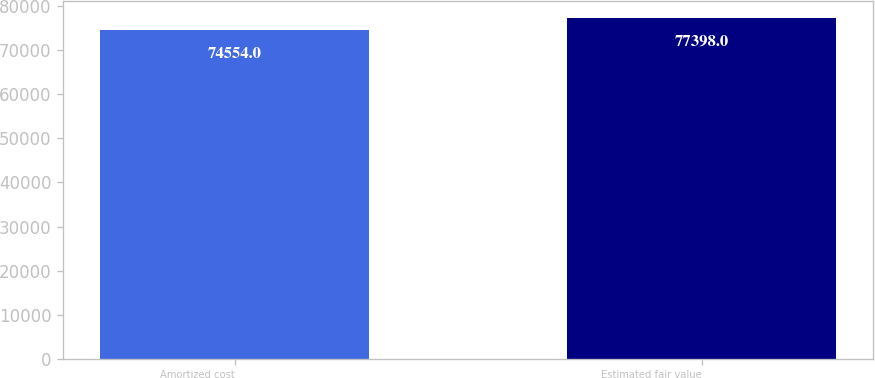<chart> <loc_0><loc_0><loc_500><loc_500><bar_chart><fcel>Amortized cost<fcel>Estimated fair value<nl><fcel>74554<fcel>77398<nl></chart> 